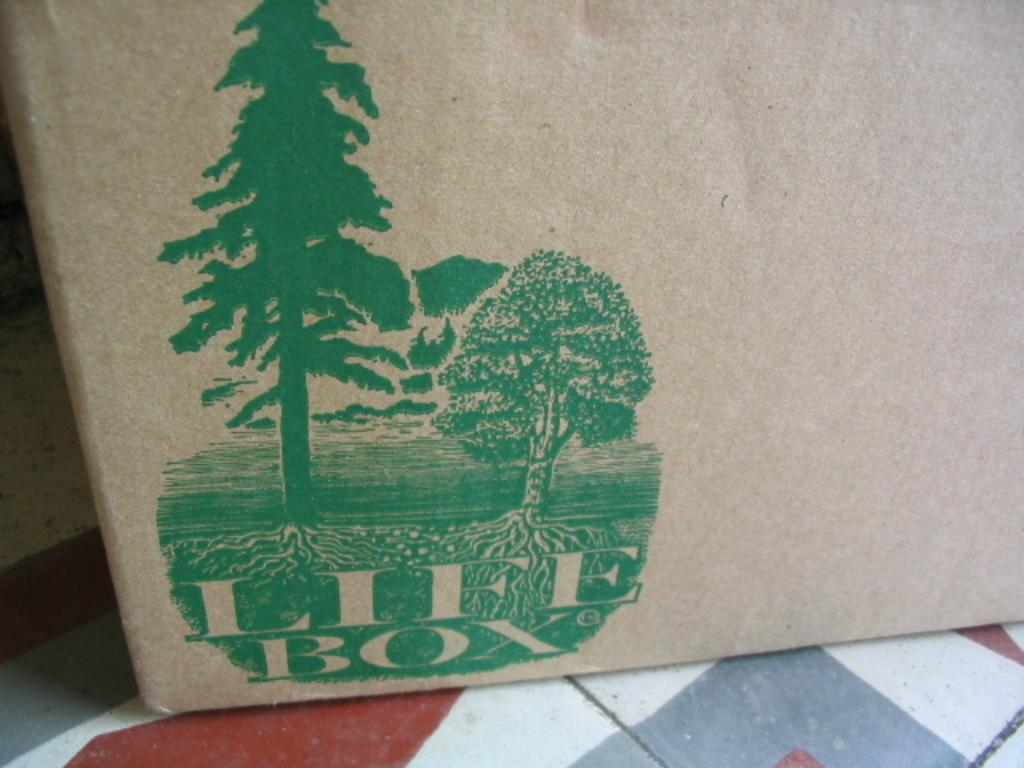What is the main subject in the center of the image? There is a cover in the center of the image. What can be observed on the cover? The cover has a print on it and there is text on the cover. What role does the father play in the image? There is no father present in the image; it only features a cover with a print and text. 